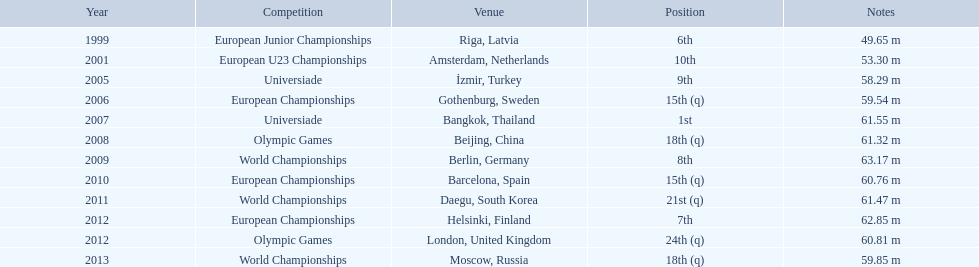What was mayer's top performance: namely, his furthest throw? 63.17 m. 